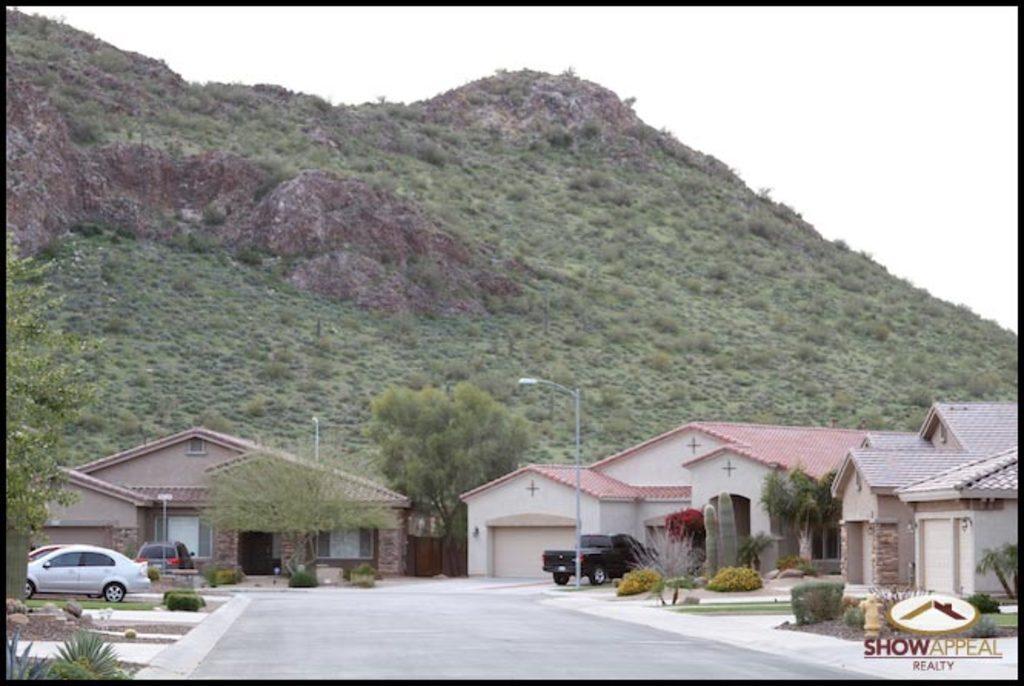In one or two sentences, can you explain what this image depicts? In the image we can see there are buildings and there are cars parked near the building. There are trees and there are street light poles on the footpath. 